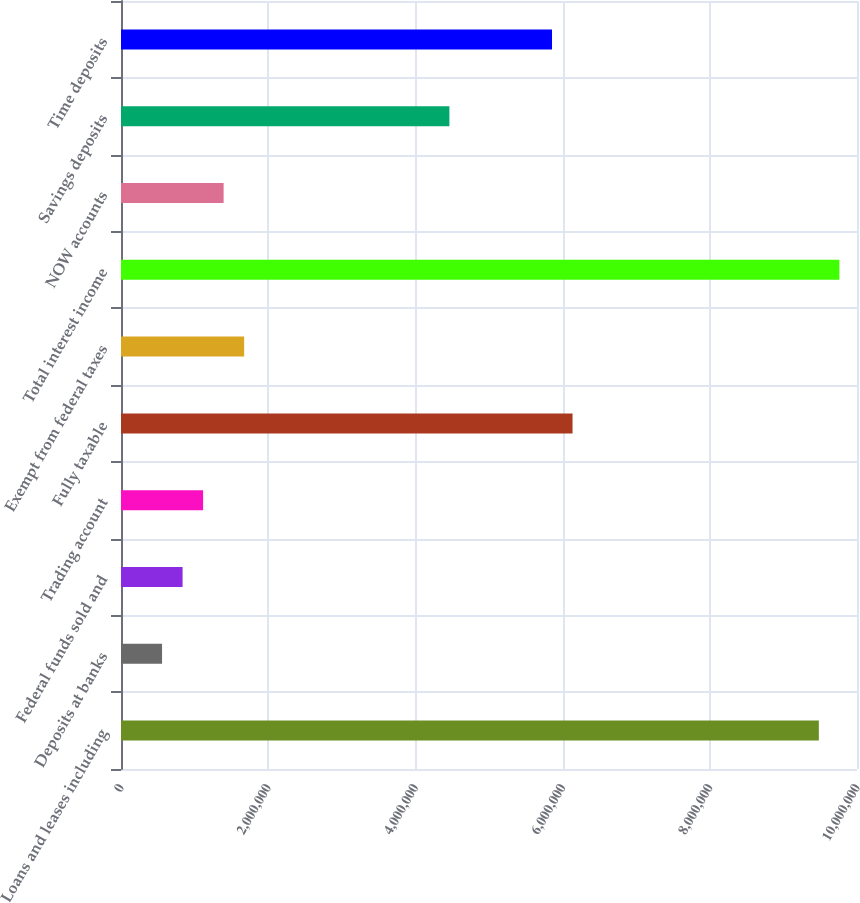<chart> <loc_0><loc_0><loc_500><loc_500><bar_chart><fcel>Loans and leases including<fcel>Deposits at banks<fcel>Federal funds sold and<fcel>Trading account<fcel>Fully taxable<fcel>Exempt from federal taxes<fcel>Total interest income<fcel>NOW accounts<fcel>Savings deposits<fcel>Time deposits<nl><fcel>9.48154e+06<fcel>557744<fcel>836613<fcel>1.11548e+06<fcel>6.13512e+06<fcel>1.67322e+06<fcel>9.76041e+06<fcel>1.39435e+06<fcel>4.46191e+06<fcel>5.85625e+06<nl></chart> 